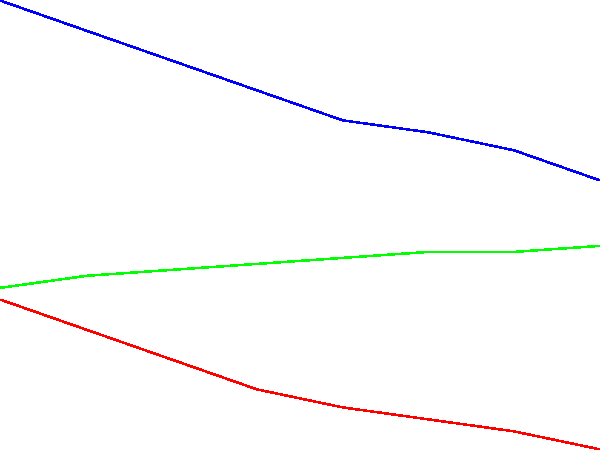Based on the line graph showing trends in a patient's heart rate, blood pressure, and oxygen saturation over a 7-day period, which physiological parameter appears to be the strongest indicator of patient recovery, and approximately how many days would you predict for full recovery? To answer this question, we need to analyze the trends of each physiological parameter:

1. Heart Rate (red line):
   - Starts at 90 bpm and steadily decreases to 65 bpm.
   - Shows a consistent downward trend, indicating improvement.

2. Blood Pressure (blue line):
   - Starts at 140 mmHg and decreases to 110 mmHg.
   - Also shows a consistent downward trend, indicating improvement.

3. Oxygen Saturation (green line):
   - Starts at 92% and increases to 99%.
   - Shows a steady upward trend, indicating improvement.

All three parameters show positive trends, but oxygen saturation appears to be the strongest indicator of recovery because:
   a) It shows the most consistent and steady improvement.
   b) It reaches the optimal level (99%) by the end of the 7-day period.

To predict full recovery time:
   - Oxygen saturation reaches 98-99% (considered normal) by day 6-7.
   - Heart rate and blood pressure are still improving but haven't fully stabilized.
   - Extrapolating the trends, we can estimate that all parameters would likely reach optimal levels in approximately 9-10 days.

Therefore, oxygen saturation is the strongest indicator of recovery, and we can predict full recovery in about 9-10 days from the start of monitoring.
Answer: Oxygen saturation; 9-10 days 